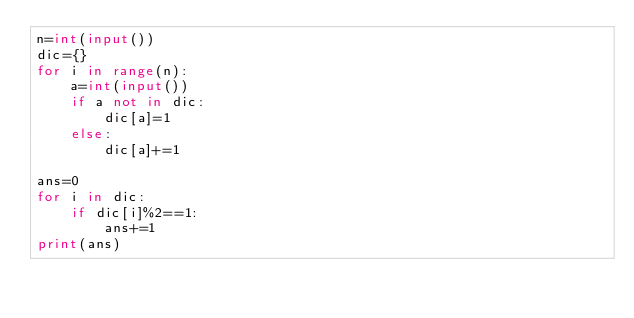<code> <loc_0><loc_0><loc_500><loc_500><_Python_>n=int(input())
dic={}
for i in range(n):
    a=int(input())
    if a not in dic:
        dic[a]=1
    else:
        dic[a]+=1

ans=0
for i in dic:
    if dic[i]%2==1:
        ans+=1
print(ans)</code> 